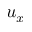<formula> <loc_0><loc_0><loc_500><loc_500>u _ { x }</formula> 